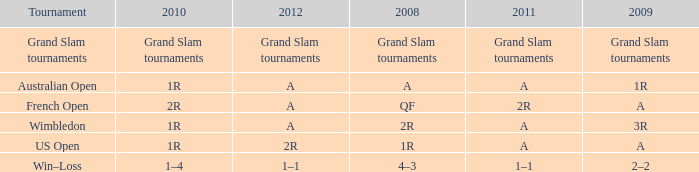Name the 2011 when 2010 is 2r 2R. 